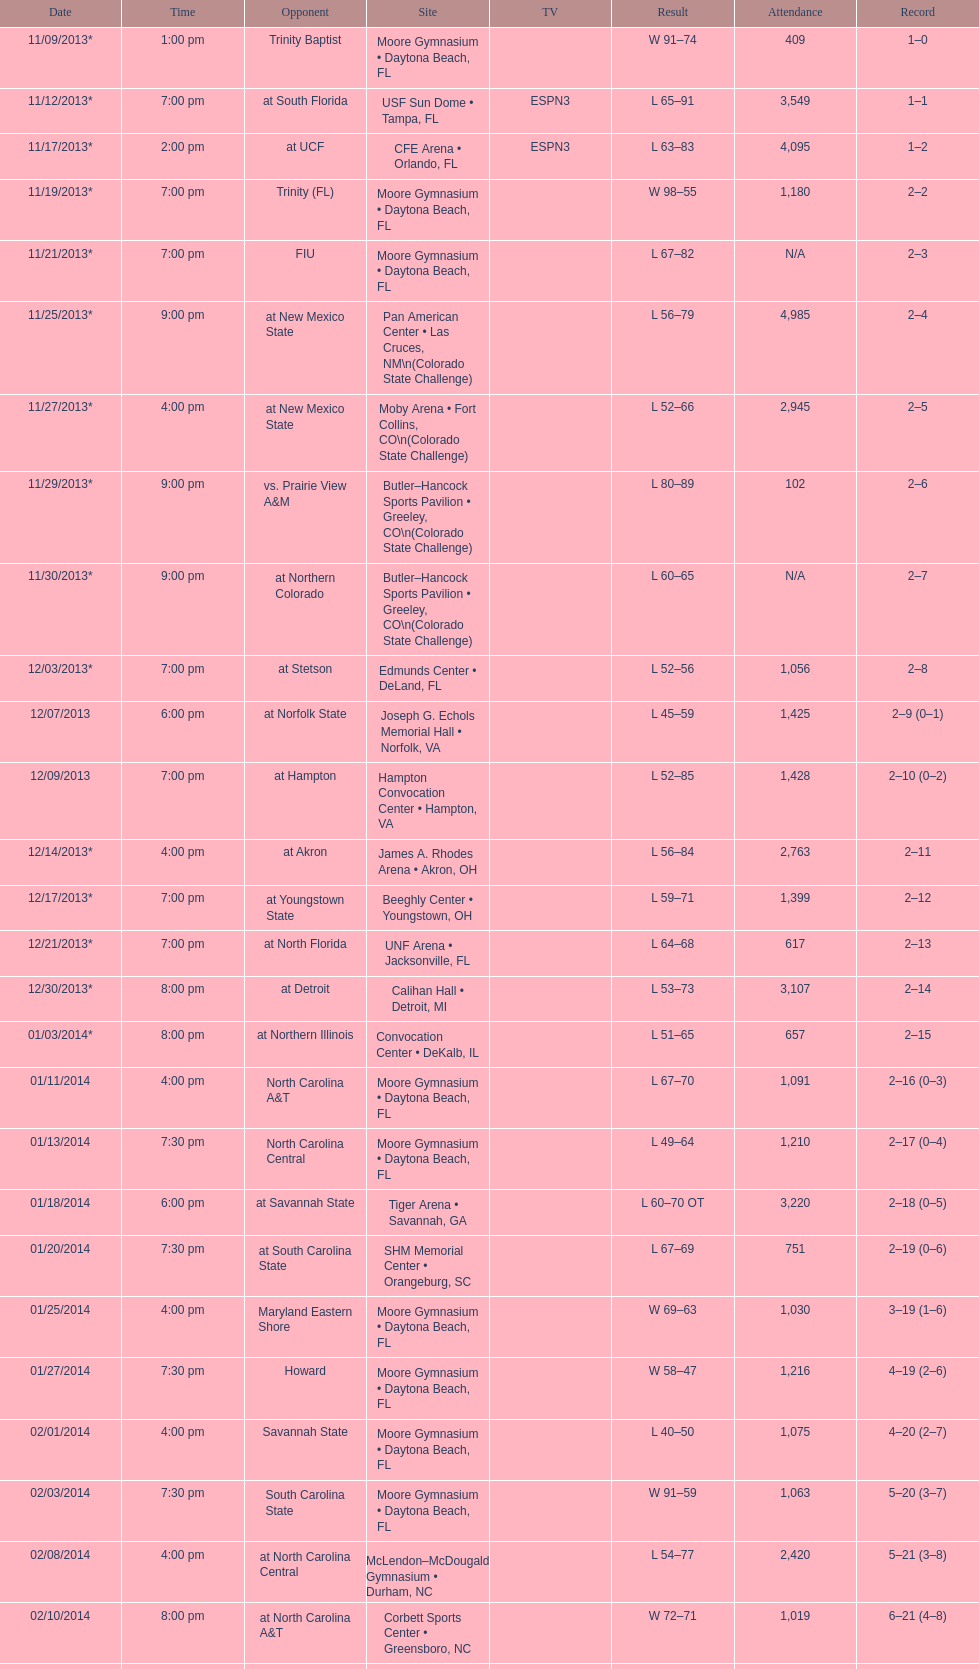Which game was won by a bigger margin, against trinity (fl) or against trinity baptist? Trinity (FL). 